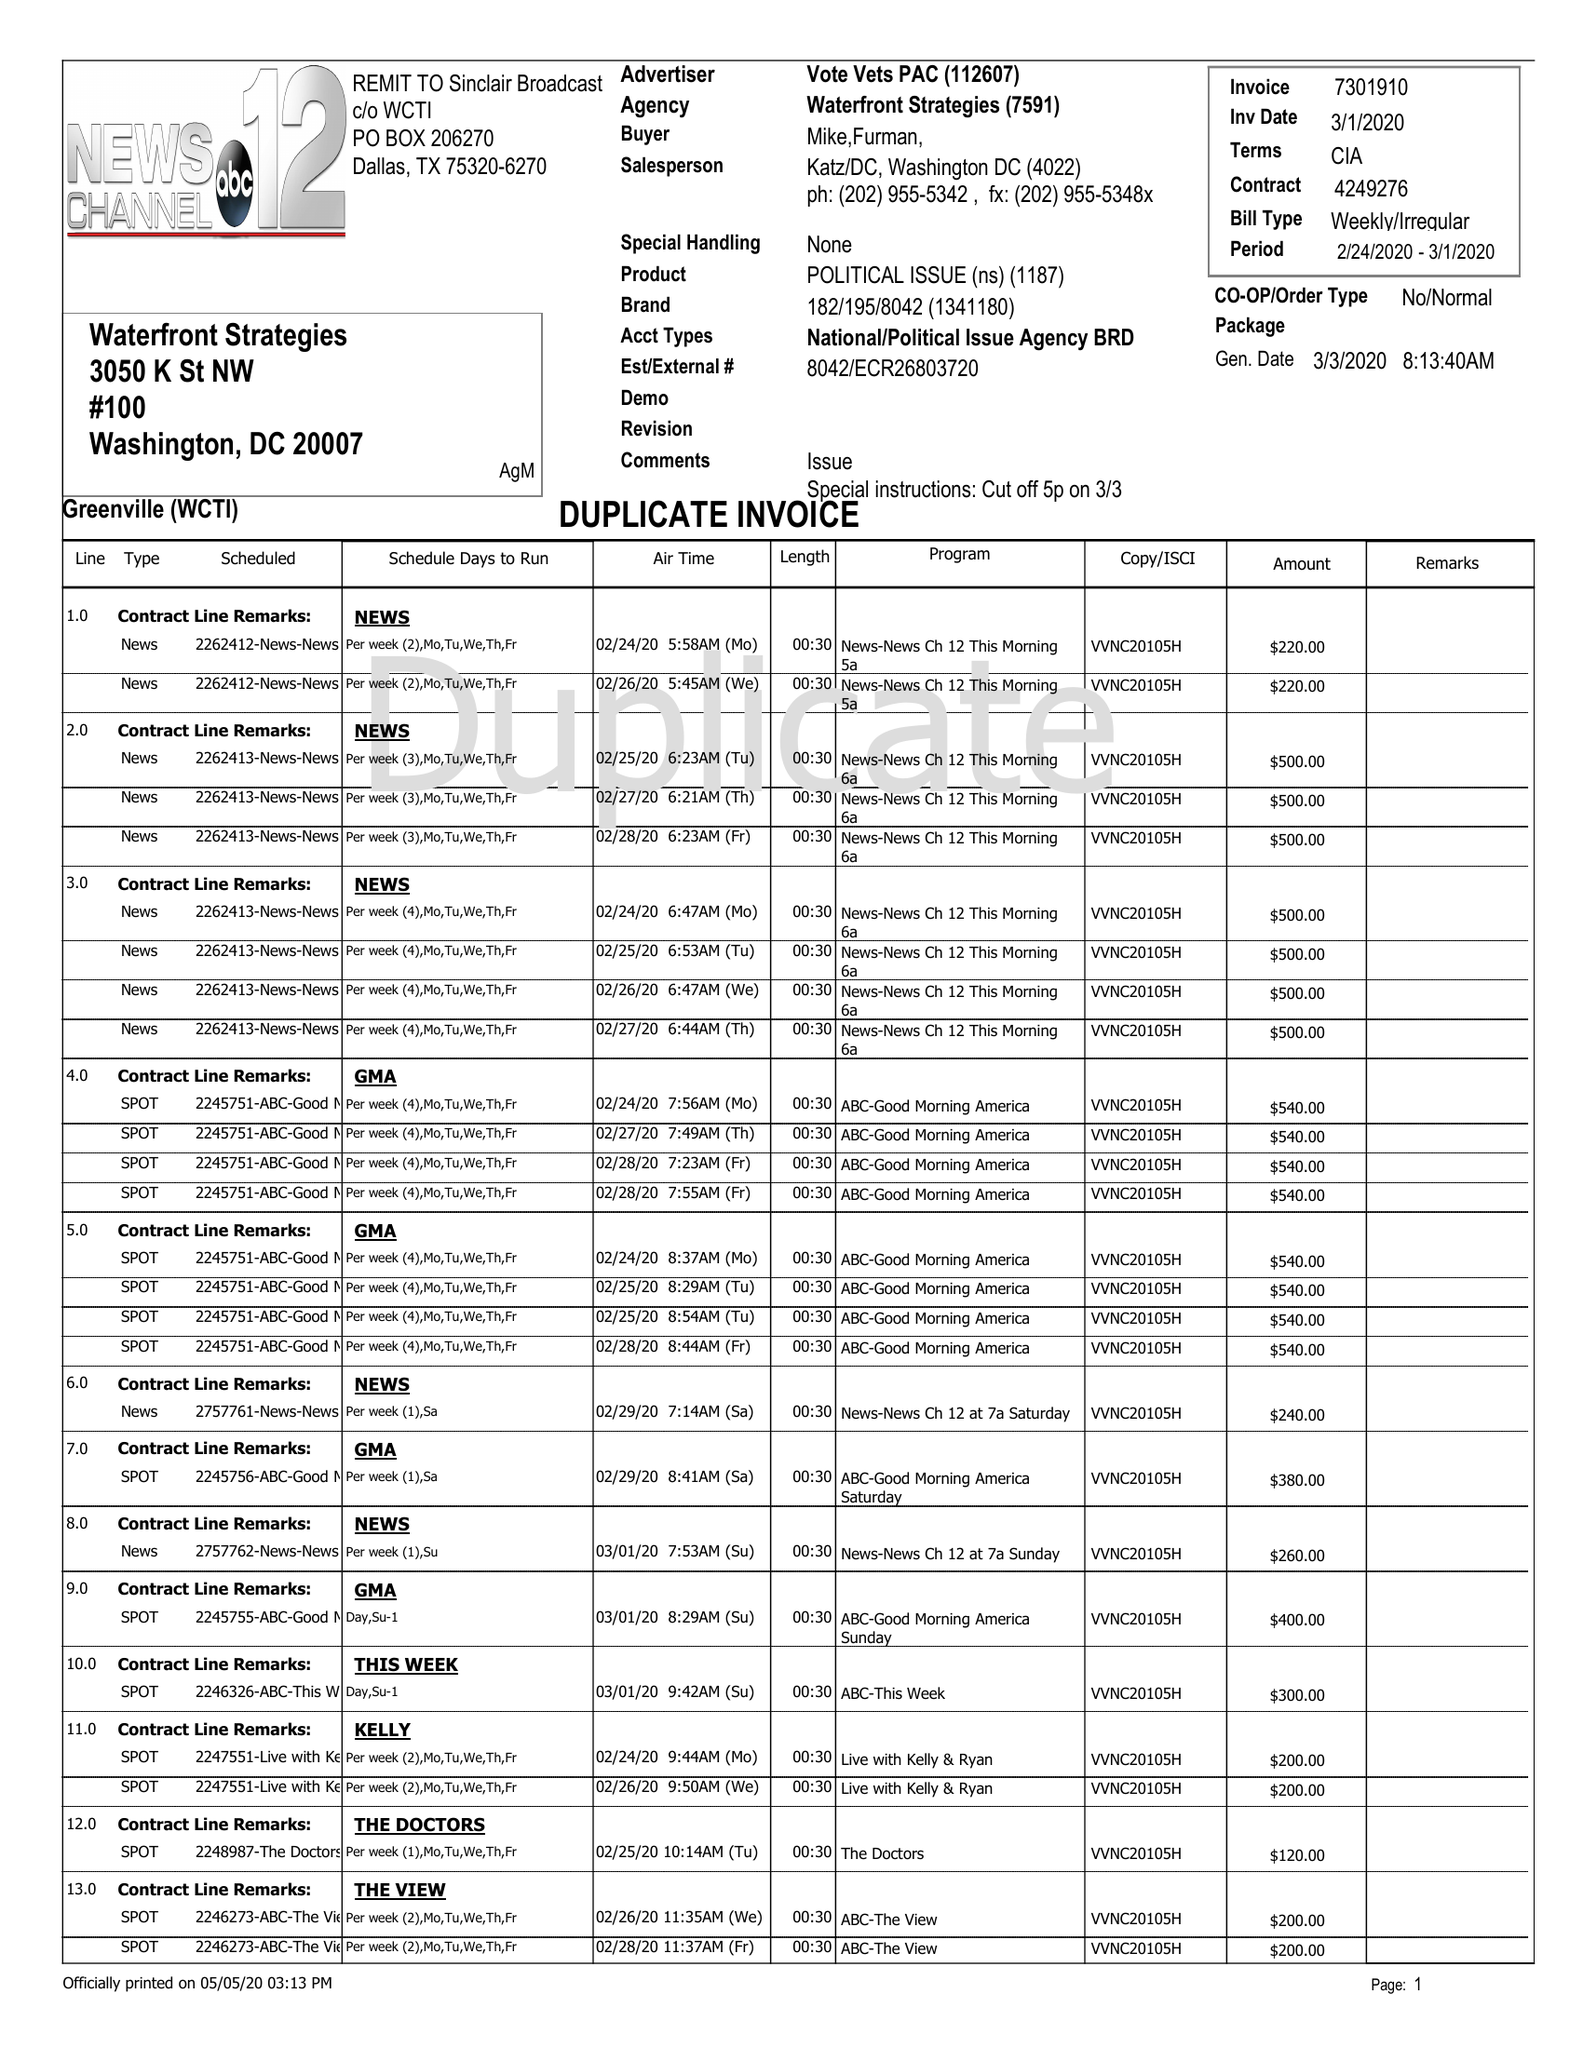What is the value for the advertiser?
Answer the question using a single word or phrase. VOTE VETS PAC 